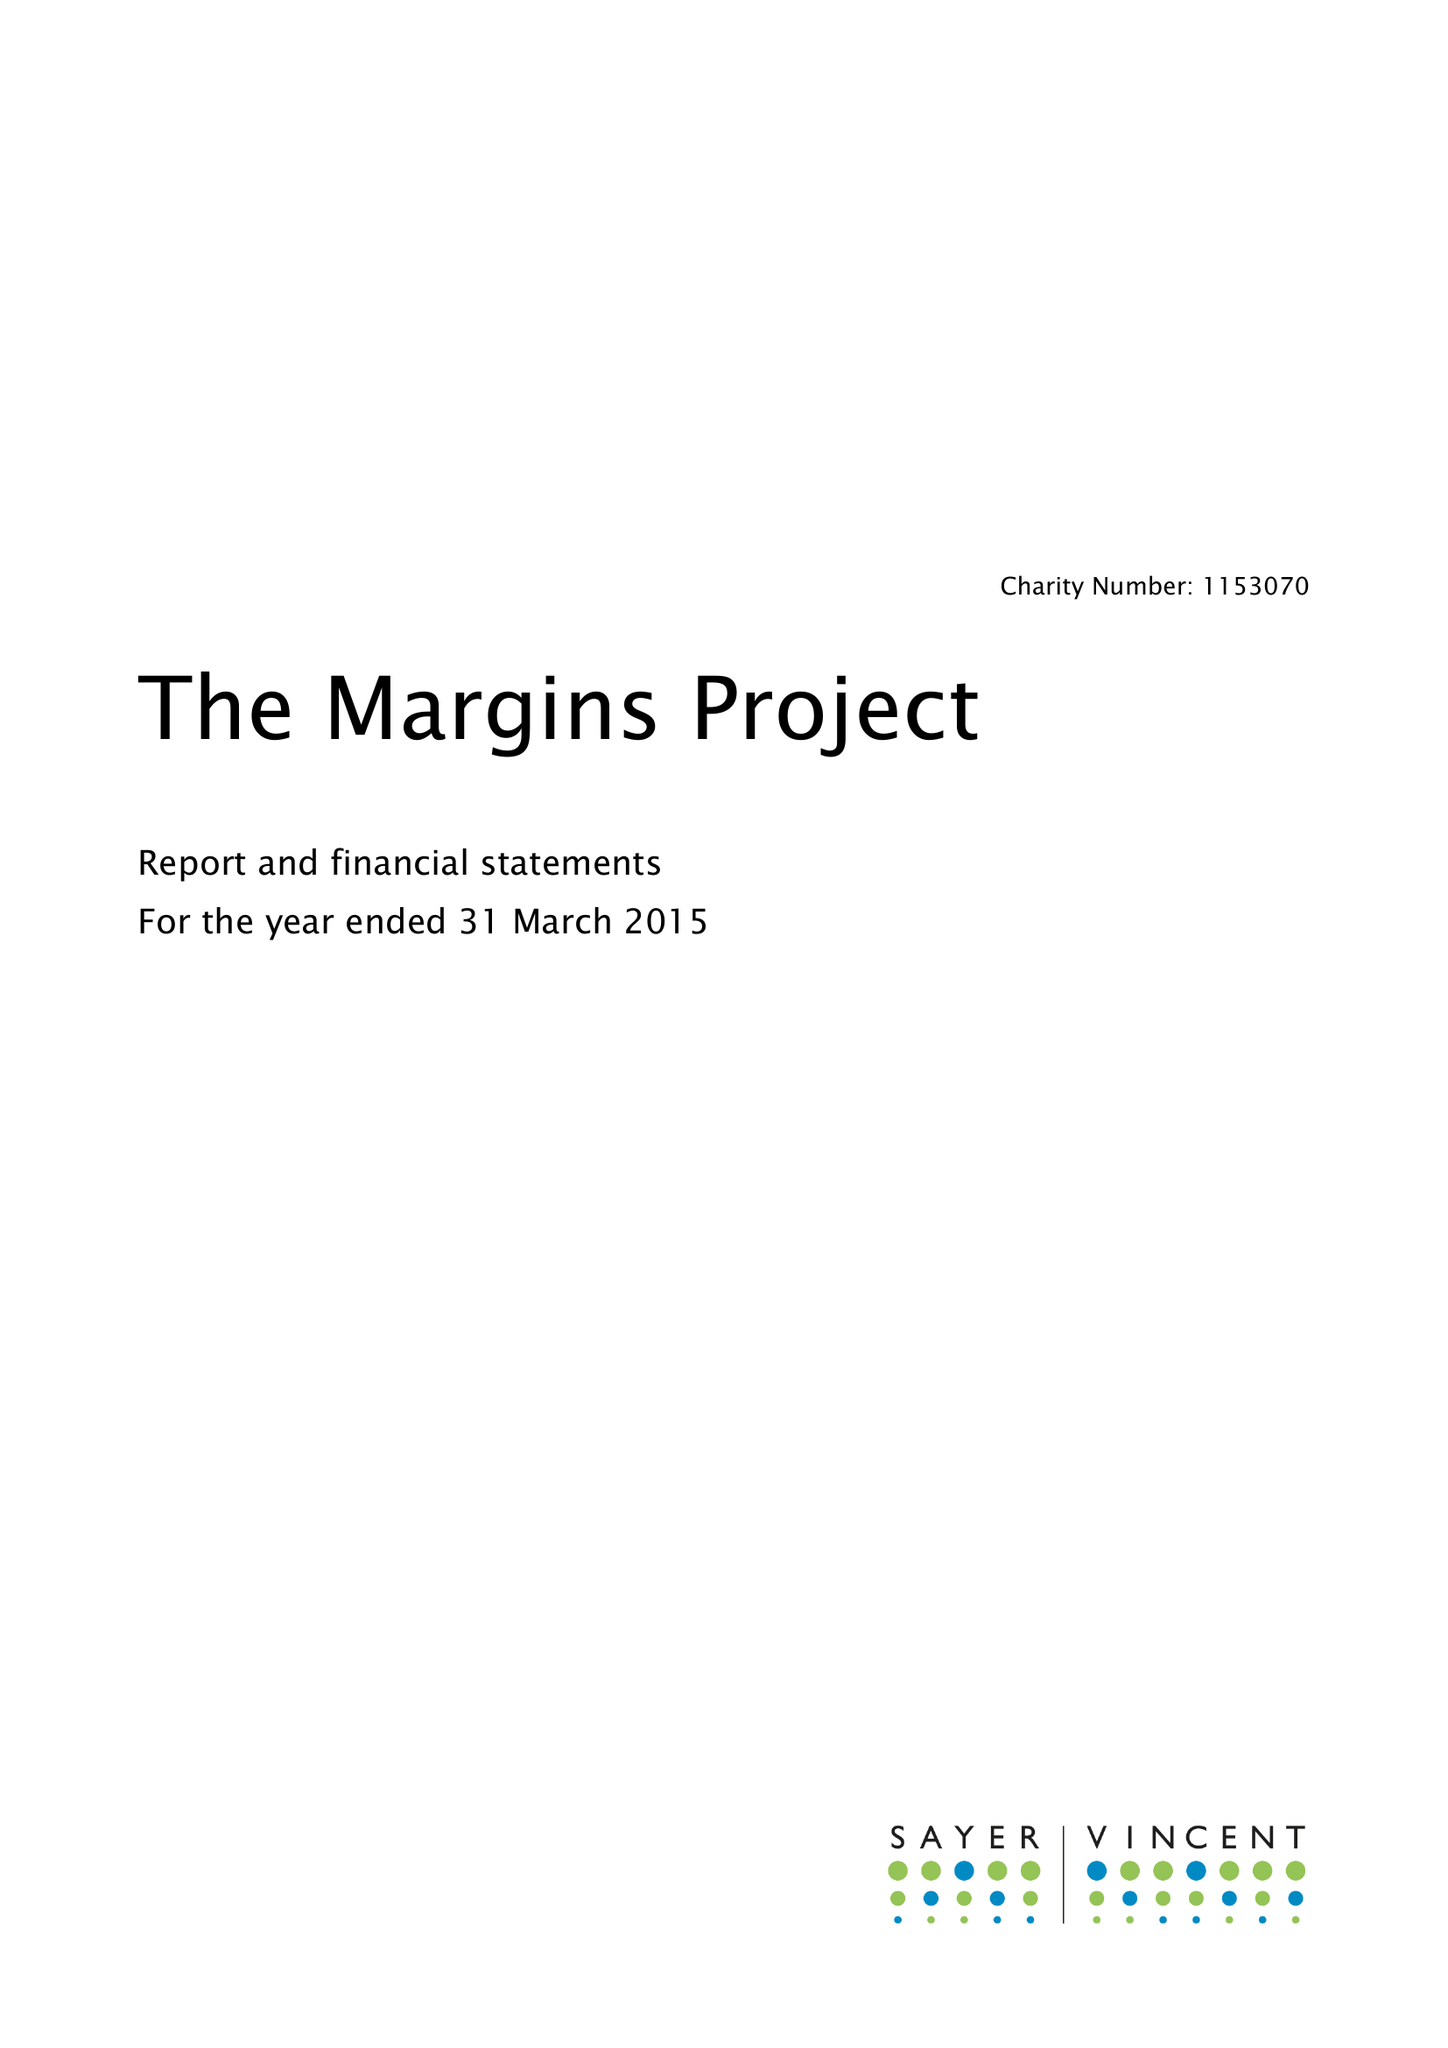What is the value for the income_annually_in_british_pounds?
Answer the question using a single word or phrase. 155971.00 